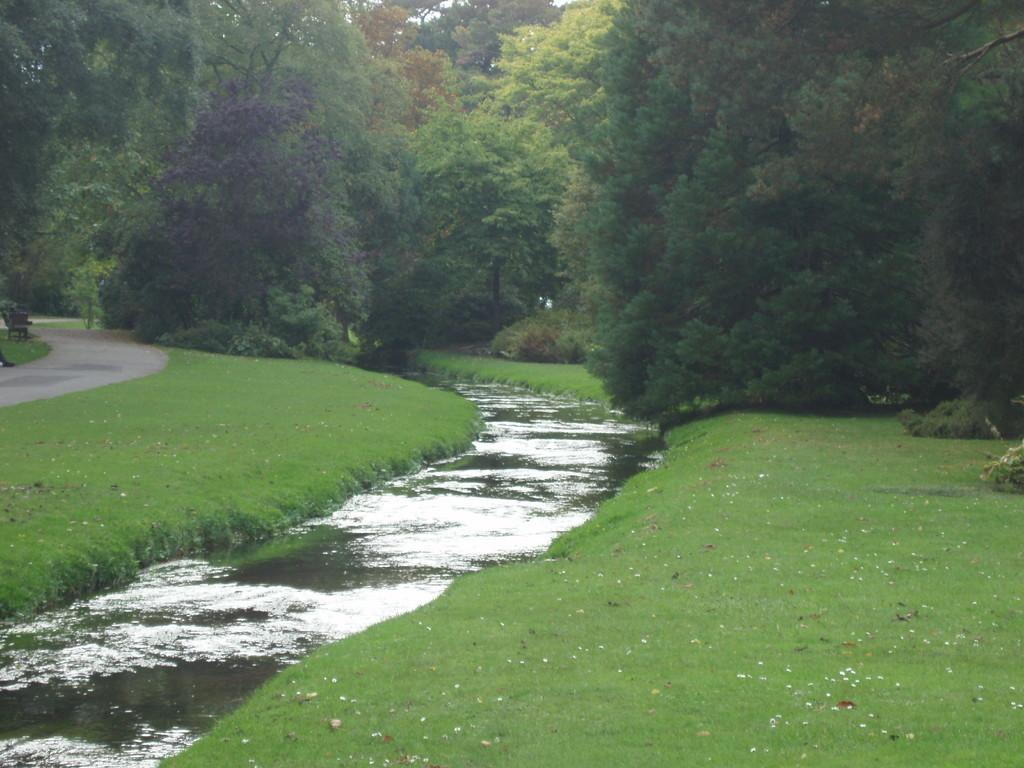What is the main feature in the center of the image? There is a canal in the center of the image. What can be seen in the background of the image? There are trees in the background of the image. Where is the walkway located in the image? The walkway is on the left side of the image. What type of vegetation is visible at the bottom of the image? Grass is visible at the bottom of the image. What type of cherry is growing on the trees in the image? There are no cherries present in the image; the trees are not specified as cherry trees. What word is written on the walkway in the image? There are no words written on the walkway in the image. 